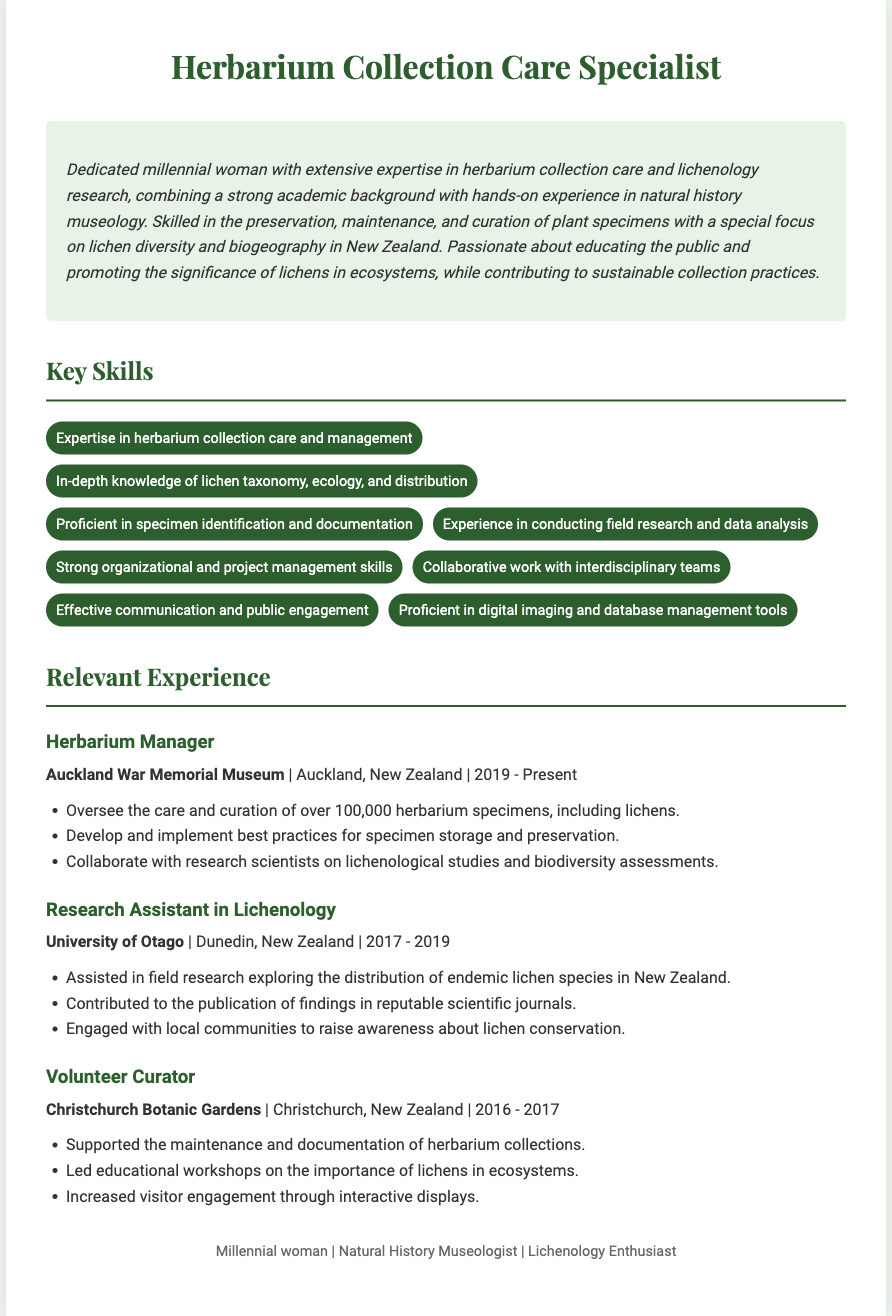what is the title of the resume? The title of the resume is displayed prominently at the top of the document.
Answer: Herbarium Collection Care Specialist who is the current employer of the Herbarium Manager? The current employer is mentioned in the experience section of the resume.
Answer: Auckland War Memorial Museum how many herbarium specimens does the Herbarium Manager oversee? This information is specified in the responsibilities of the Herbarium Manager role.
Answer: over 100,000 what position did the individual hold from 2017 to 2019? The position is noted in the relevant experience section of the resume concerning time periods.
Answer: Research Assistant in Lichenology which university did the Research Assistant work at? The university is mentioned alongside the job title and its location in the relevant experience section.
Answer: University of Otago what is one of the key skills listed in the resume? This can be found in the skills section, which outlines essential competencies.
Answer: Expertise in herbarium collection care and management what was the focus of the educational workshops led by the Volunteer Curator? This detail is provided in the experience section describing the Volunteer Curator's role.
Answer: importance of lichens in ecosystems when did the individual start working as the Herbarium Manager? The date is indicated within the employment timeline for the Herbarium Manager role.
Answer: 2019 how has the individual contributed to lichen conservation? This contribution is highlighted in the duties of the Research Assistant and Volunteer Curator roles.
Answer: Engaged with local communities to raise awareness about lichen conservation 